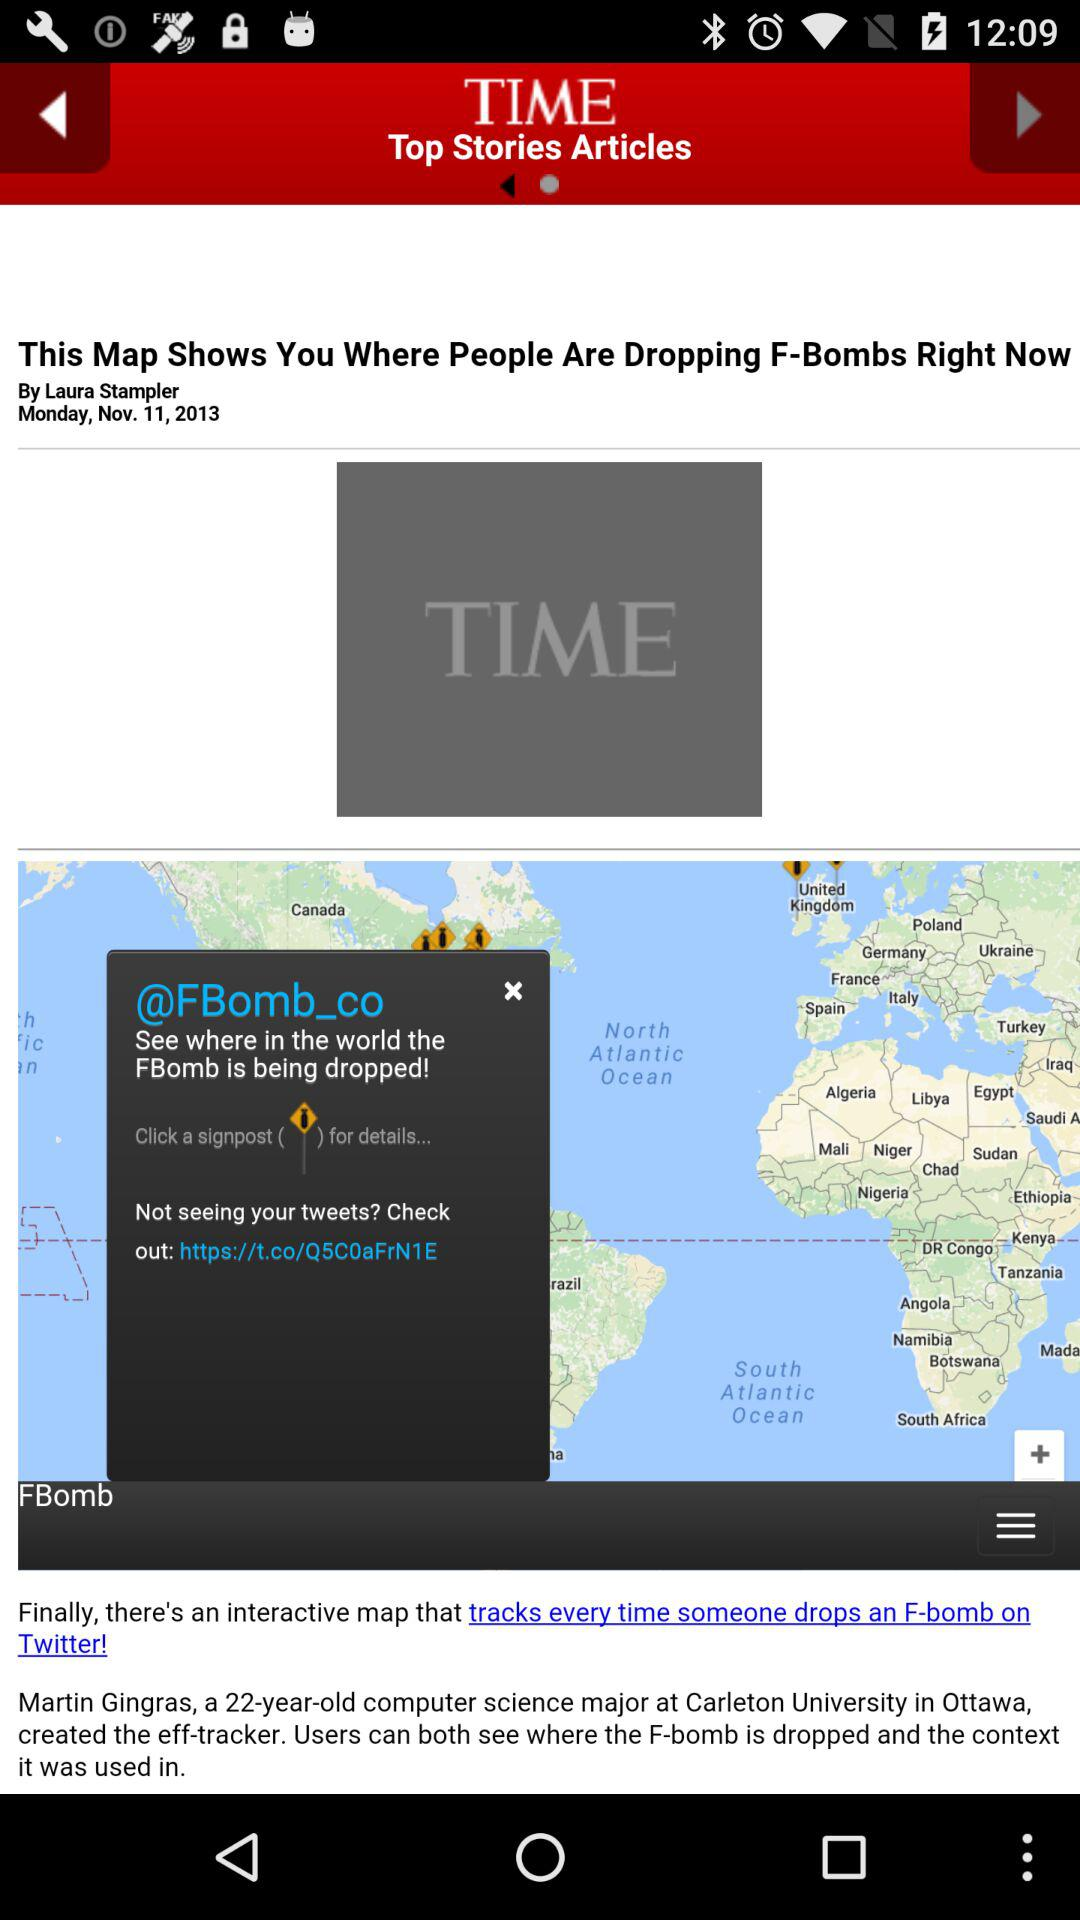What is the app name? The app name is "TIME". 